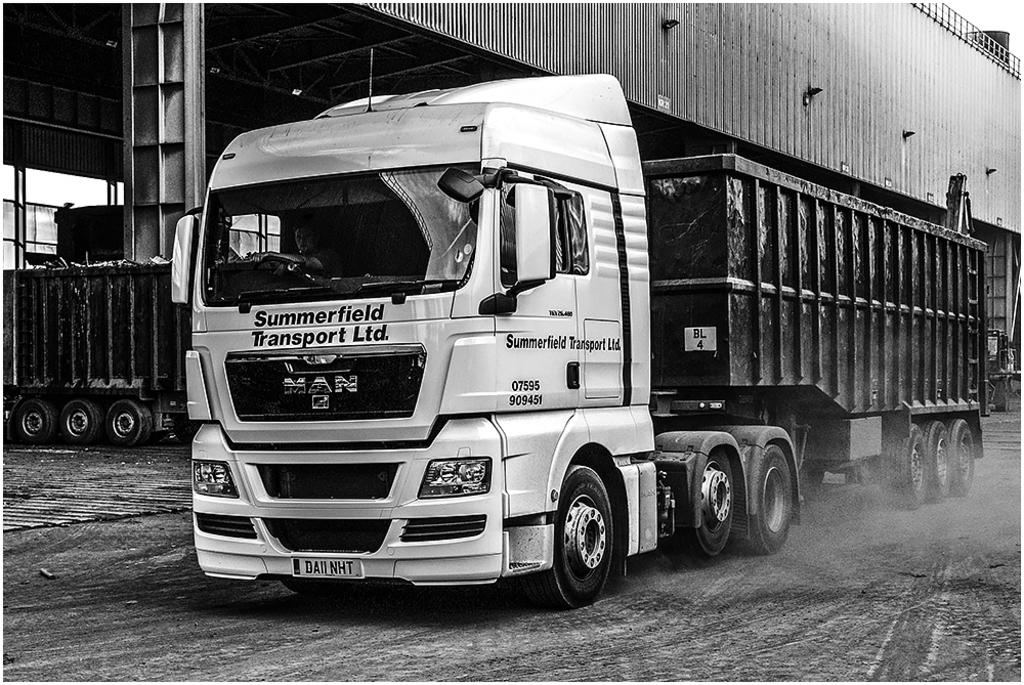What is on the ground in the image? There is a vehicle on the ground in the image. Who or what is inside the vehicle? A person is inside the vehicle. Can you describe the background of the image? There is a vehicle, a shelter, rods, and some unspecified objects in the background of the image. How many boats are visible in the image? There are no boats present in the image. What type of canvas is being used by the person inside the vehicle? There is no canvas visible in the image, and the person inside the vehicle is not engaged in any activity that would require a canvas. 